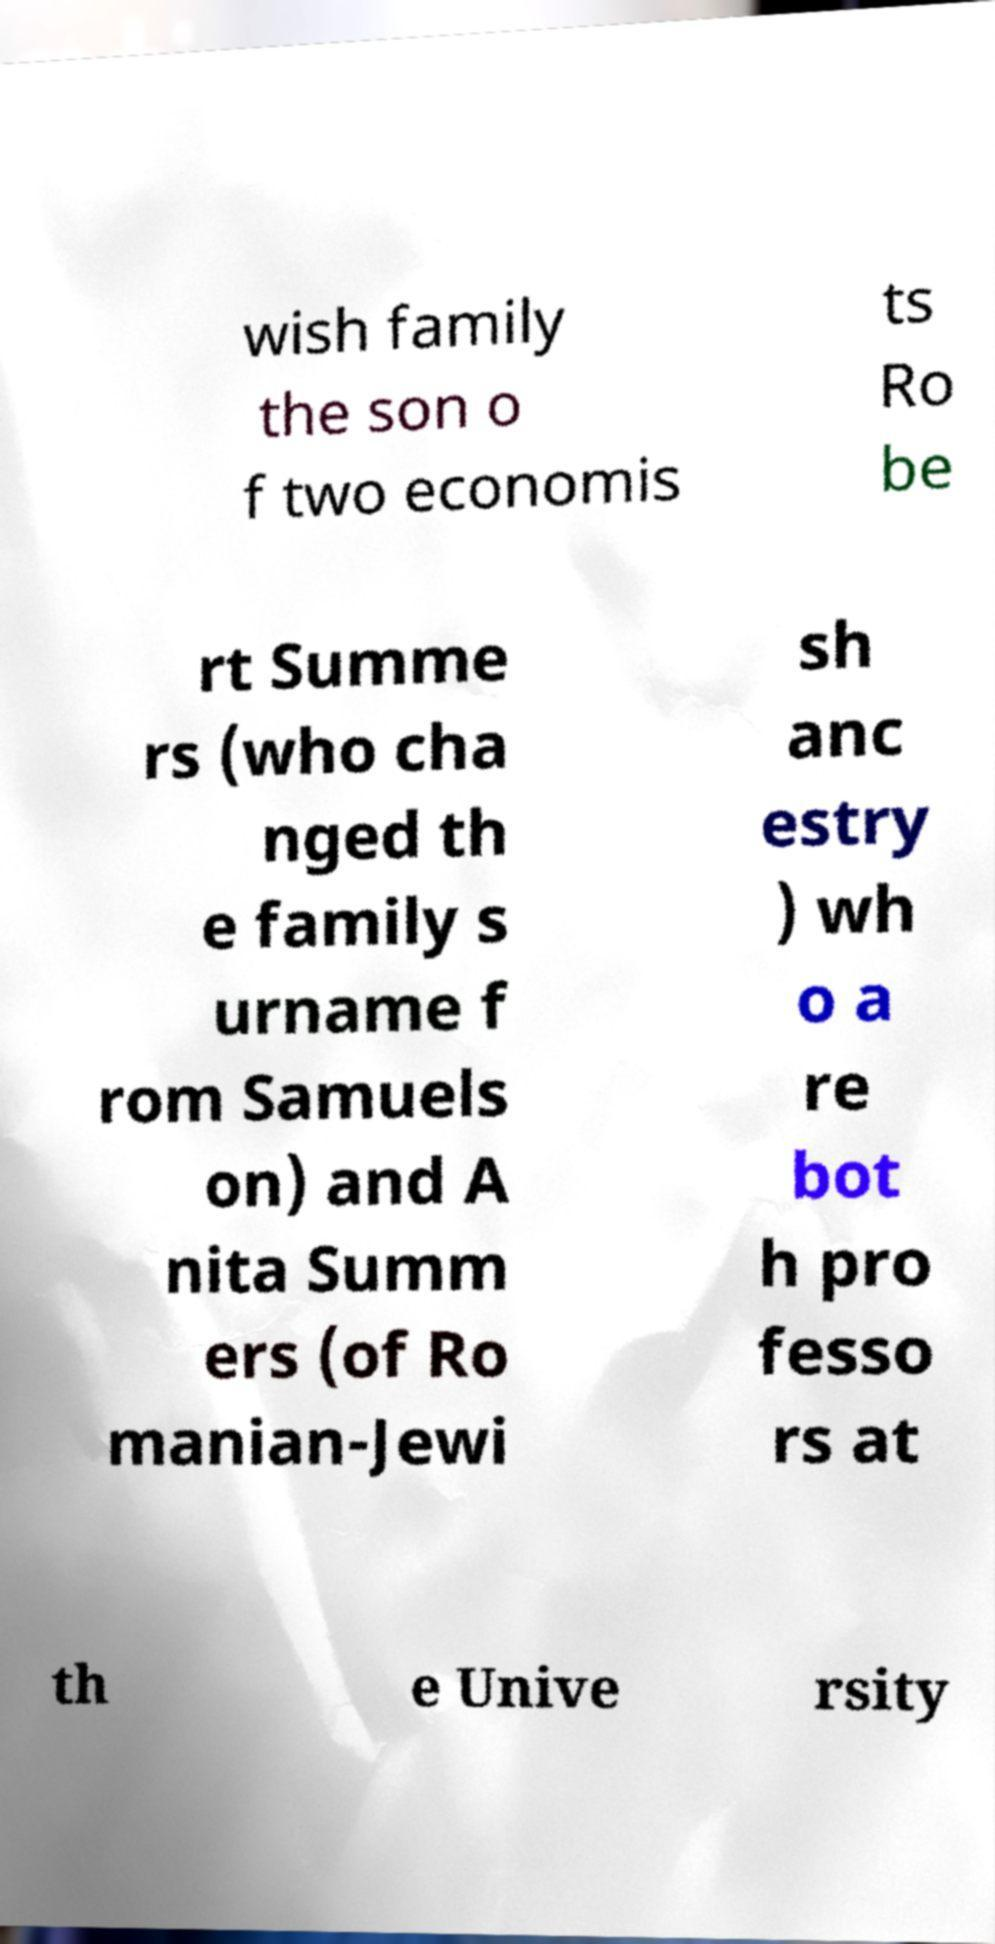Please read and relay the text visible in this image. What does it say? wish family the son o f two economis ts Ro be rt Summe rs (who cha nged th e family s urname f rom Samuels on) and A nita Summ ers (of Ro manian-Jewi sh anc estry ) wh o a re bot h pro fesso rs at th e Unive rsity 